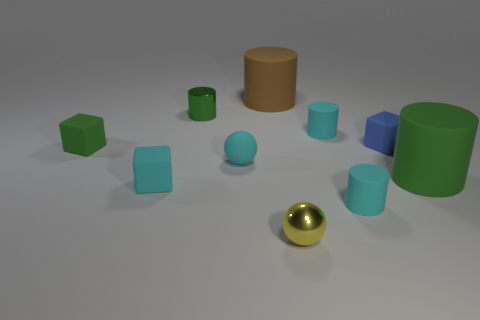How does the color diversity in the image contribute to its aesthetic? The range of colors provides a rich visual experience, creating a spectrum that is pleasing to the eye. The cool blues and greens suggest a calm atmosphere, while the lone pastel orange cylinder adds a warm contrast that draws interest and balances the composition. 